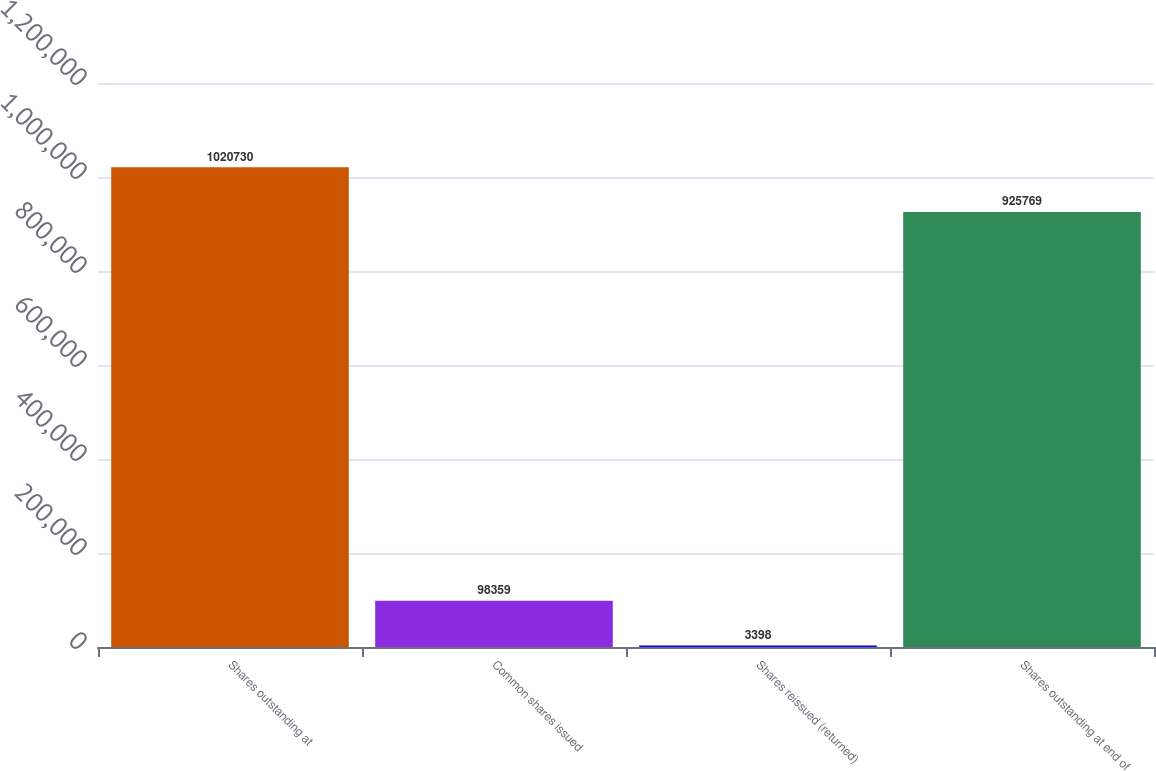Convert chart. <chart><loc_0><loc_0><loc_500><loc_500><bar_chart><fcel>Shares outstanding at<fcel>Common shares issued<fcel>Shares reissued (returned)<fcel>Shares outstanding at end of<nl><fcel>1.02073e+06<fcel>98359<fcel>3398<fcel>925769<nl></chart> 